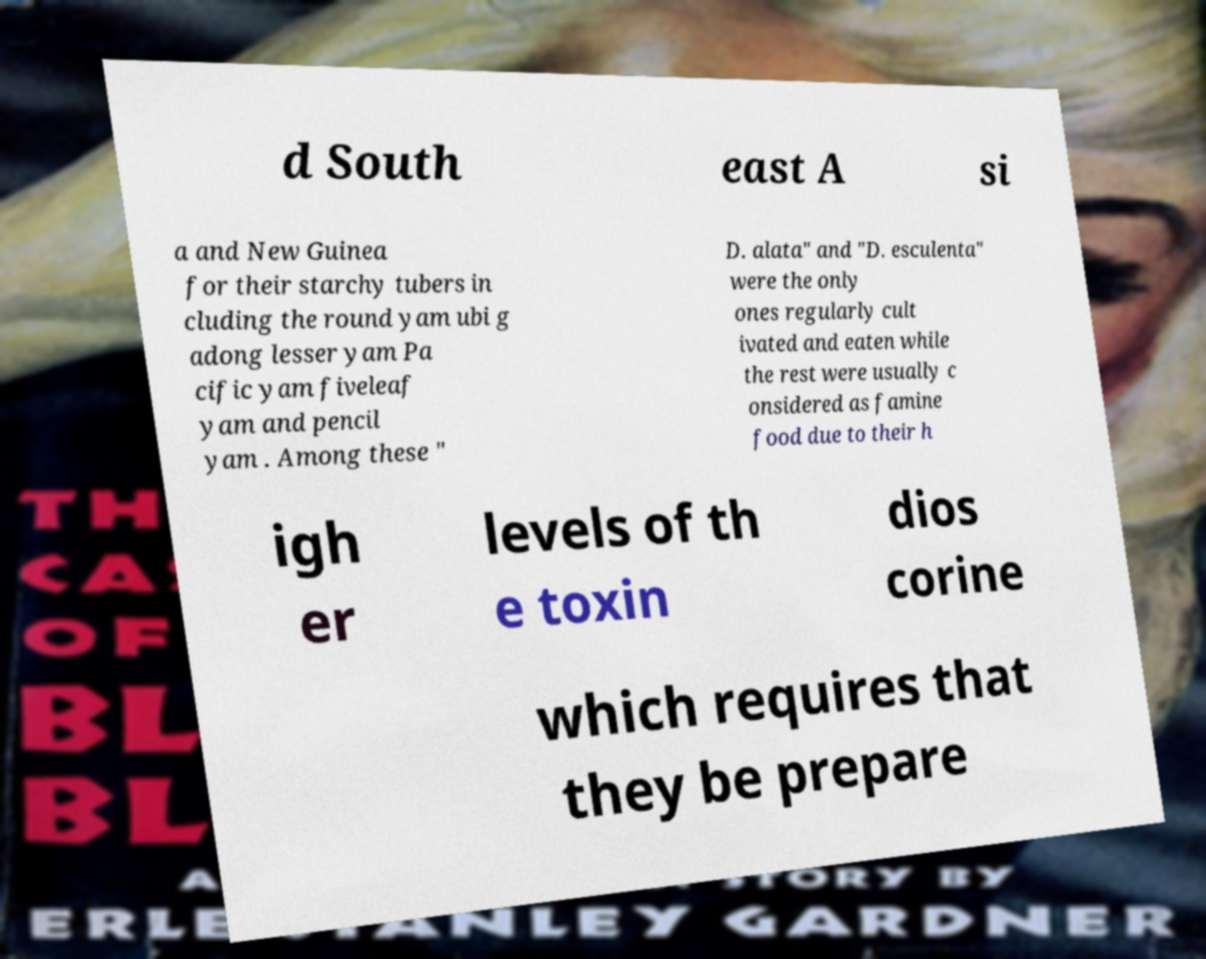There's text embedded in this image that I need extracted. Can you transcribe it verbatim? d South east A si a and New Guinea for their starchy tubers in cluding the round yam ubi g adong lesser yam Pa cific yam fiveleaf yam and pencil yam . Among these " D. alata" and "D. esculenta" were the only ones regularly cult ivated and eaten while the rest were usually c onsidered as famine food due to their h igh er levels of th e toxin dios corine which requires that they be prepare 